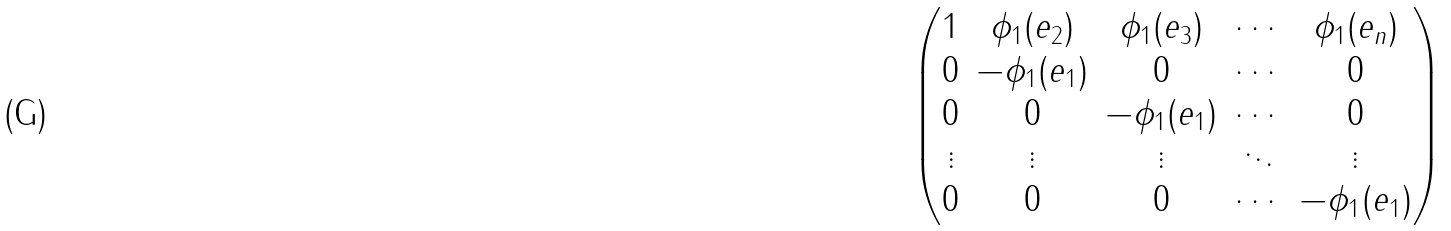Convert formula to latex. <formula><loc_0><loc_0><loc_500><loc_500>\begin{pmatrix} 1 & \phi _ { 1 } ( e _ { 2 } ) & \phi _ { 1 } ( e _ { 3 } ) & \cdots & \phi _ { 1 } ( e _ { n } ) \\ 0 & - \phi _ { 1 } ( e _ { 1 } ) & 0 & \cdots & 0 \\ 0 & 0 & - \phi _ { 1 } ( e _ { 1 } ) & \cdots & 0 \\ \vdots & \vdots & \vdots & \ddots & \vdots \\ 0 & 0 & 0 & \cdots & - \phi _ { 1 } ( e _ { 1 } ) \end{pmatrix}</formula> 